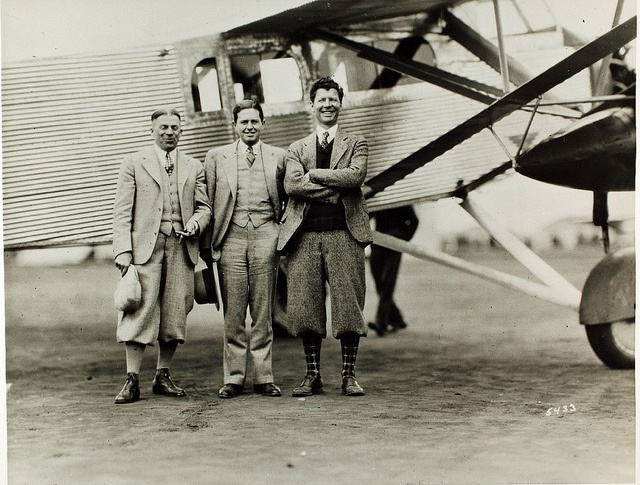Describe the objects in this image and their specific colors. I can see airplane in ivory, lightgray, black, and darkgray tones, people in ivory, black, gray, and darkgray tones, people in ivory, darkgray, black, gray, and lightgray tones, people in ivory, darkgray, gray, and black tones, and people in ivory, black, gray, and darkgray tones in this image. 